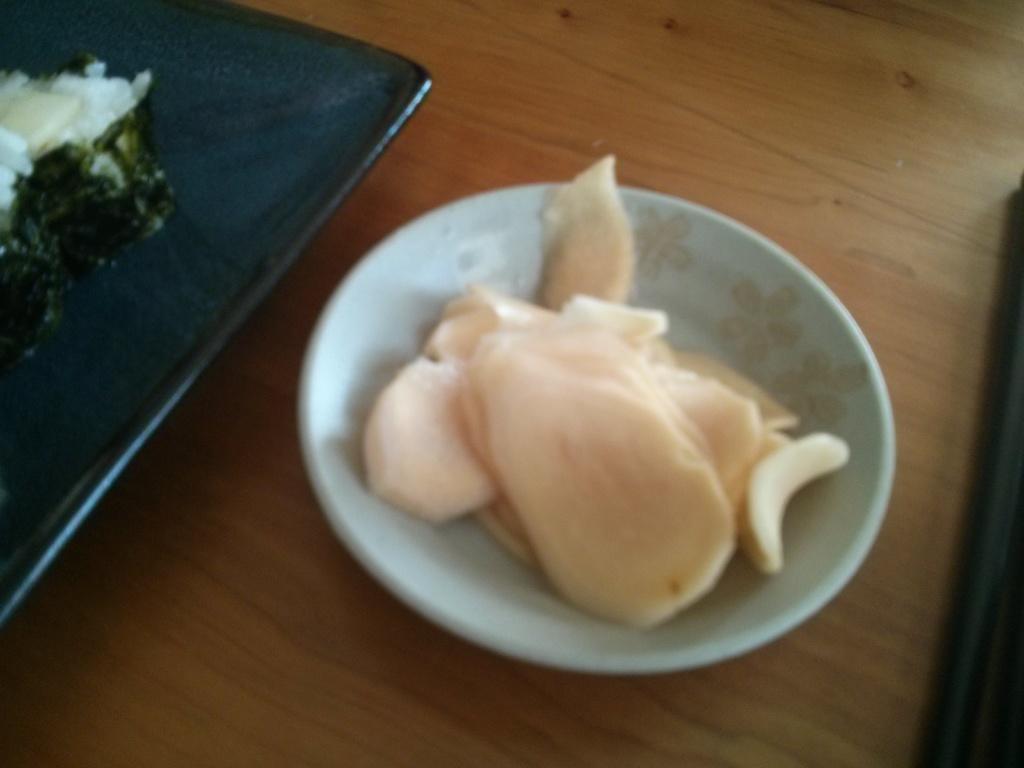Can you describe this image briefly? In this image there are food items in a bowl and on the plate , on the wooden board. 